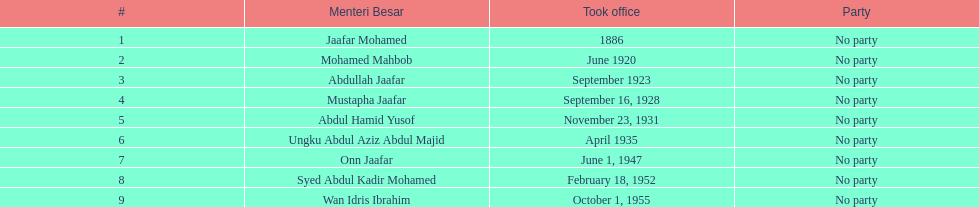Who was in office previous to abdullah jaafar? Mohamed Mahbob. 